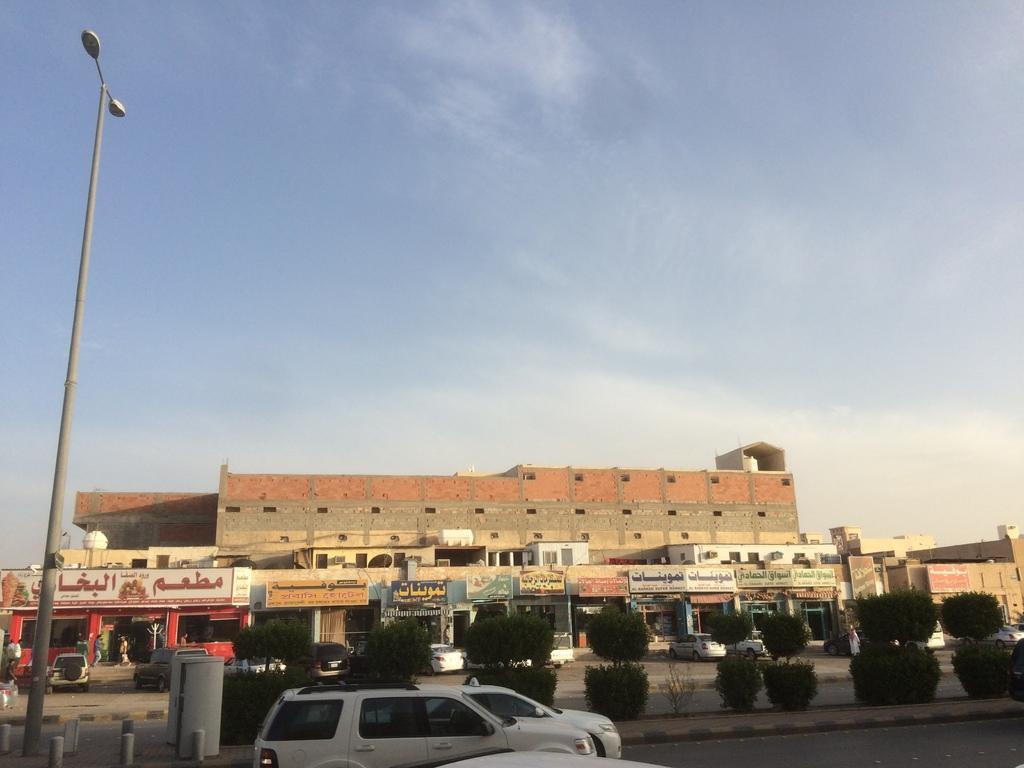In one or two sentences, can you explain what this image depicts? In this image I can see few vehicles, plants, a pole, few lights, few buildings, number of boards and on these boards I can see something is written. I can also see the sky in background. 